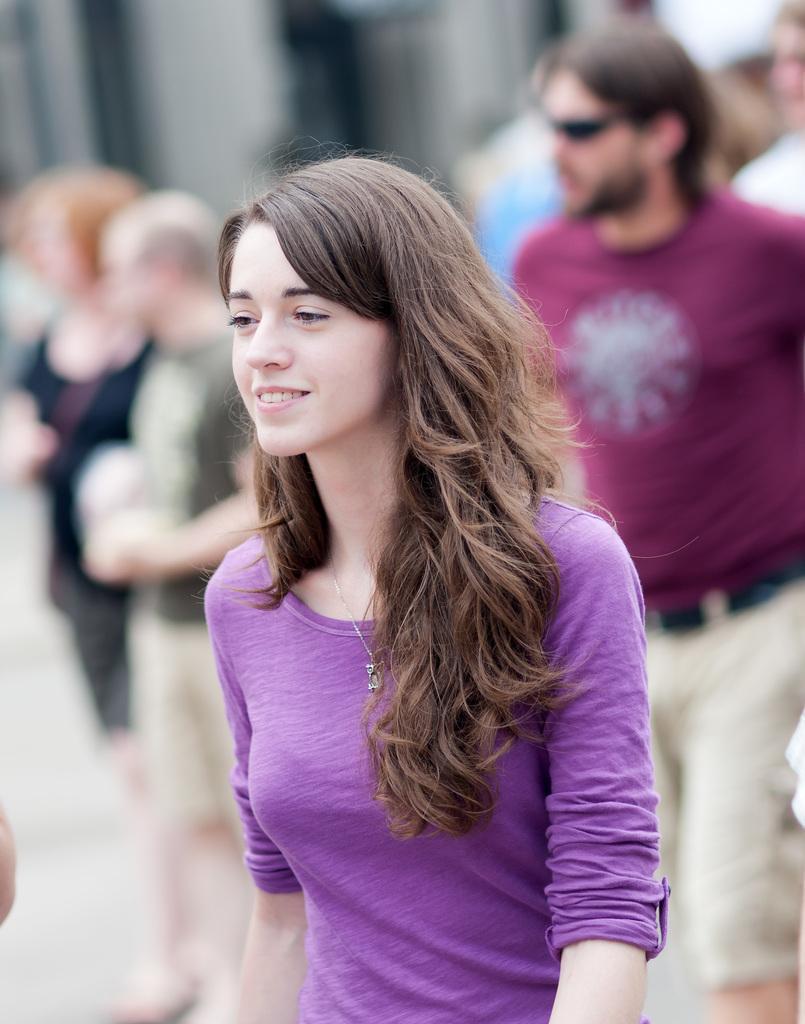Can you describe this image briefly? This image is taken outdoors. In this image the background is a little blurred. A few people are walking on the road and a few are standing. In the middle of the image a girl is walking and she is with a smiling face. 